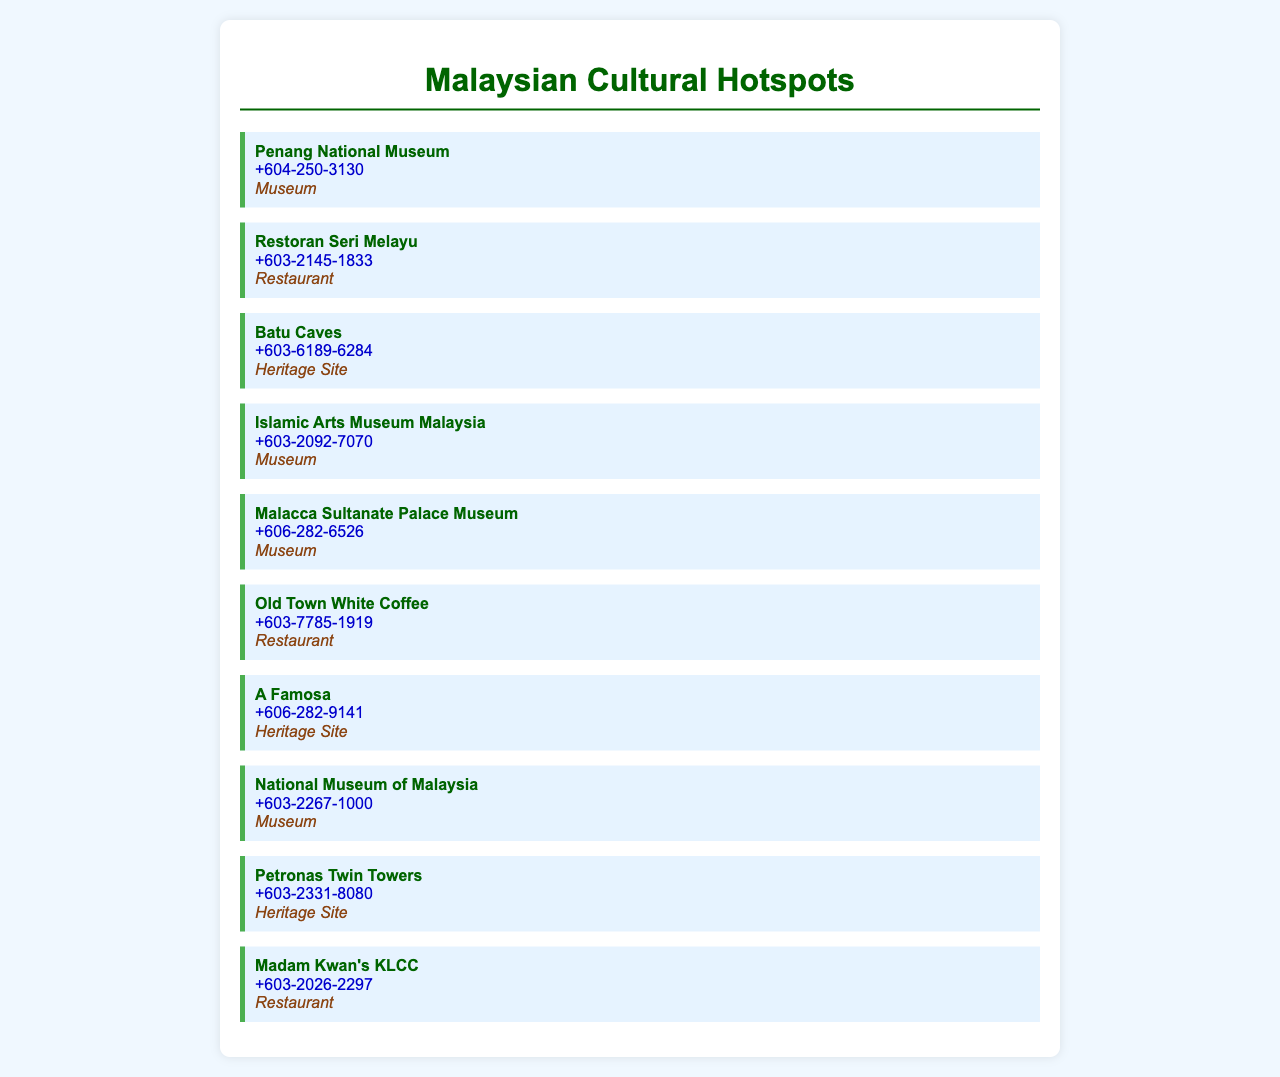what is the phone number for Penang National Museum? The document lists the phone number for Penang National Museum as +604-250-3130.
Answer: +604-250-3130 which restaurant's phone number is +603-2145-1833? The restaurant with the phone number +603-2145-1833 is Restoran Seri Melayu.
Answer: Restoran Seri Melayu how many museums are listed in the document? The document lists a total of 5 museums under the Museum category.
Answer: 5 what category does Batu Caves belong to? According to the document, Batu Caves is categorized as a Heritage Site.
Answer: Heritage Site which heritage site has the phone number +603-2331-8080? The heritage site with the phone number +603-2331-8080 is Petronas Twin Towers.
Answer: Petronas Twin Towers what is the name of the restaurant located in KLCC? The document states that the restaurant located in KLCC is called Madam Kwan's KLCC.
Answer: Madam Kwan's KLCC which museum has the number +603-2092-7070? The museum with the phone number +603-2092-7070 is the Islamic Arts Museum Malaysia.
Answer: Islamic Arts Museum Malaysia how many restaurants are listed in total? There are 3 restaurants listed in the document.
Answer: 3 what is the phone number for Malacca Sultanate Palace Museum? The document lists the phone number for Malacca Sultanate Palace Museum as +606-282-6526.
Answer: +606-282-6526 